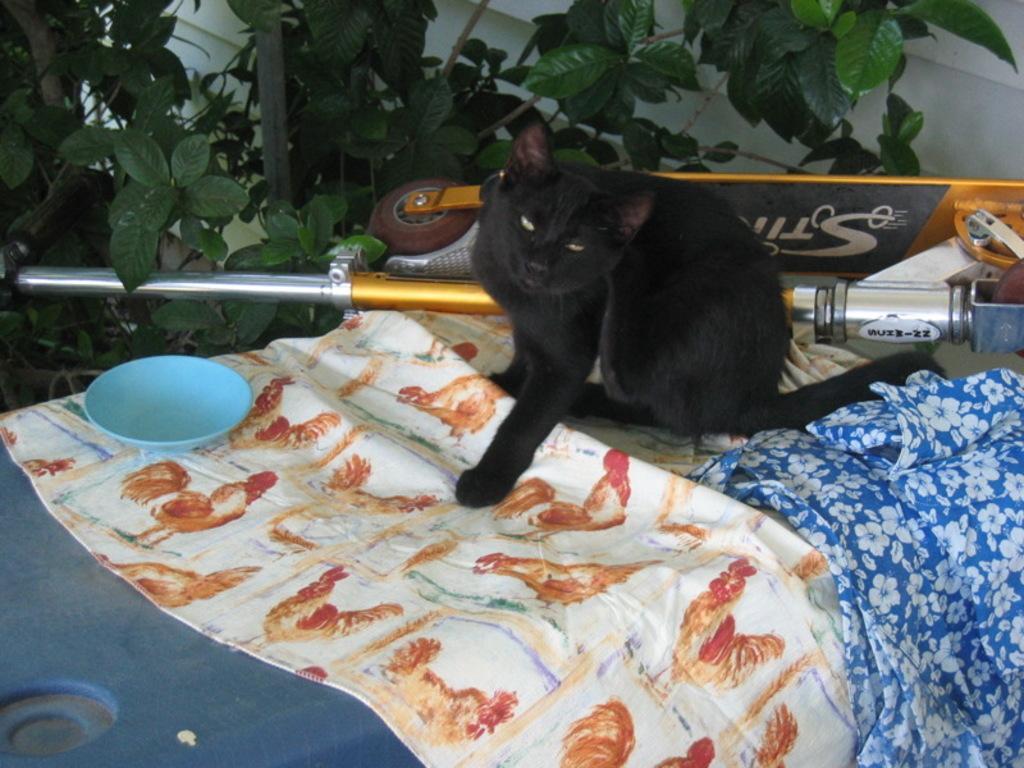How would you summarize this image in a sentence or two? In this image, in the middle, we can see a cat sitting on the table. On that table, we can see two maids and a bowl. In the background, we can see a rod and a vehicle, we can also see some trees and a wall. 